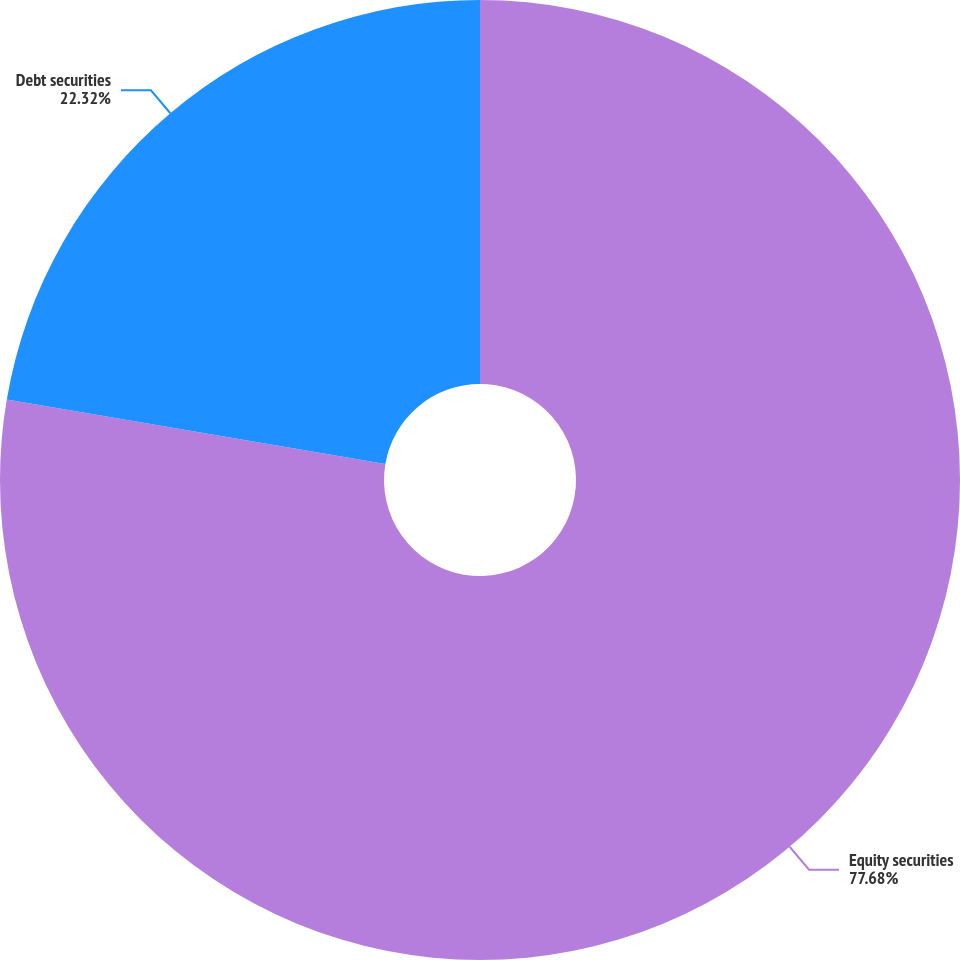Convert chart. <chart><loc_0><loc_0><loc_500><loc_500><pie_chart><fcel>Equity securities<fcel>Debt securities<nl><fcel>77.68%<fcel>22.32%<nl></chart> 